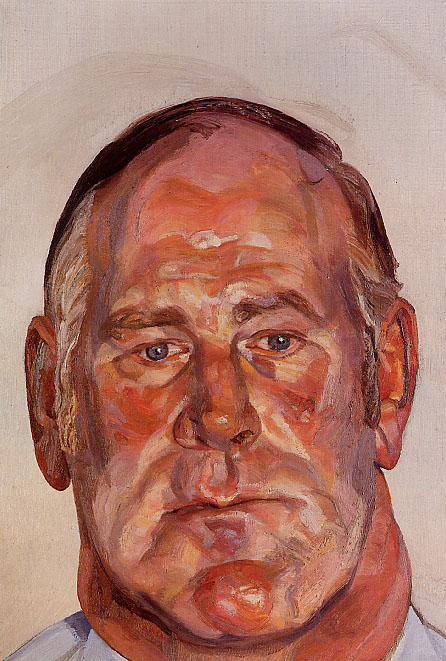Describe a day in the life of this man, based on the image. A day in the life of this man might begin with quiet moments of reflection, as suggested by his meditative expression. He could be someone who has experienced much in life and now cherishes the simple, peaceful routines of daily existence. Perhaps he starts his morning with a stroll through a nearby park, enjoying the solitude and the sights and sounds of nature. Throughout the day, he might engage in activities that allow him to connect with his thoughts and emotions, such as reading, painting, or listening to classical music. In the evening, he might sit in his favorite chair by the window, a cup of tea in hand, as he watches the sunset and reflects on the moments that have shaped his journey. His life, much like the painting, is full of depth and quiet emotional nuance. 